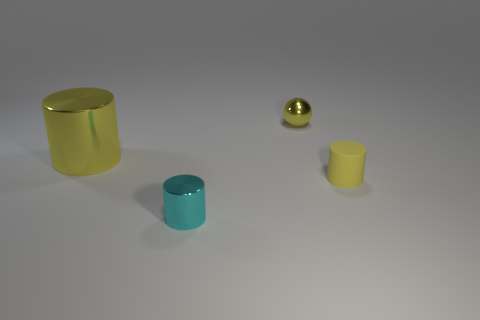Add 2 big red spheres. How many objects exist? 6 Subtract all balls. How many objects are left? 3 Subtract all green cylinders. Subtract all yellow rubber things. How many objects are left? 3 Add 2 tiny matte things. How many tiny matte things are left? 3 Add 3 big purple objects. How many big purple objects exist? 3 Subtract 0 brown cubes. How many objects are left? 4 